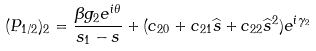<formula> <loc_0><loc_0><loc_500><loc_500>( P _ { 1 / 2 } ) _ { 2 } = \frac { \beta g _ { 2 } e ^ { i \theta } } { s _ { 1 } - s } + ( c _ { 2 0 } + c _ { 2 1 } \widehat { s } + c _ { 2 2 } { \widehat { s } } ^ { 2 } ) e ^ { i \gamma _ { 2 } }</formula> 